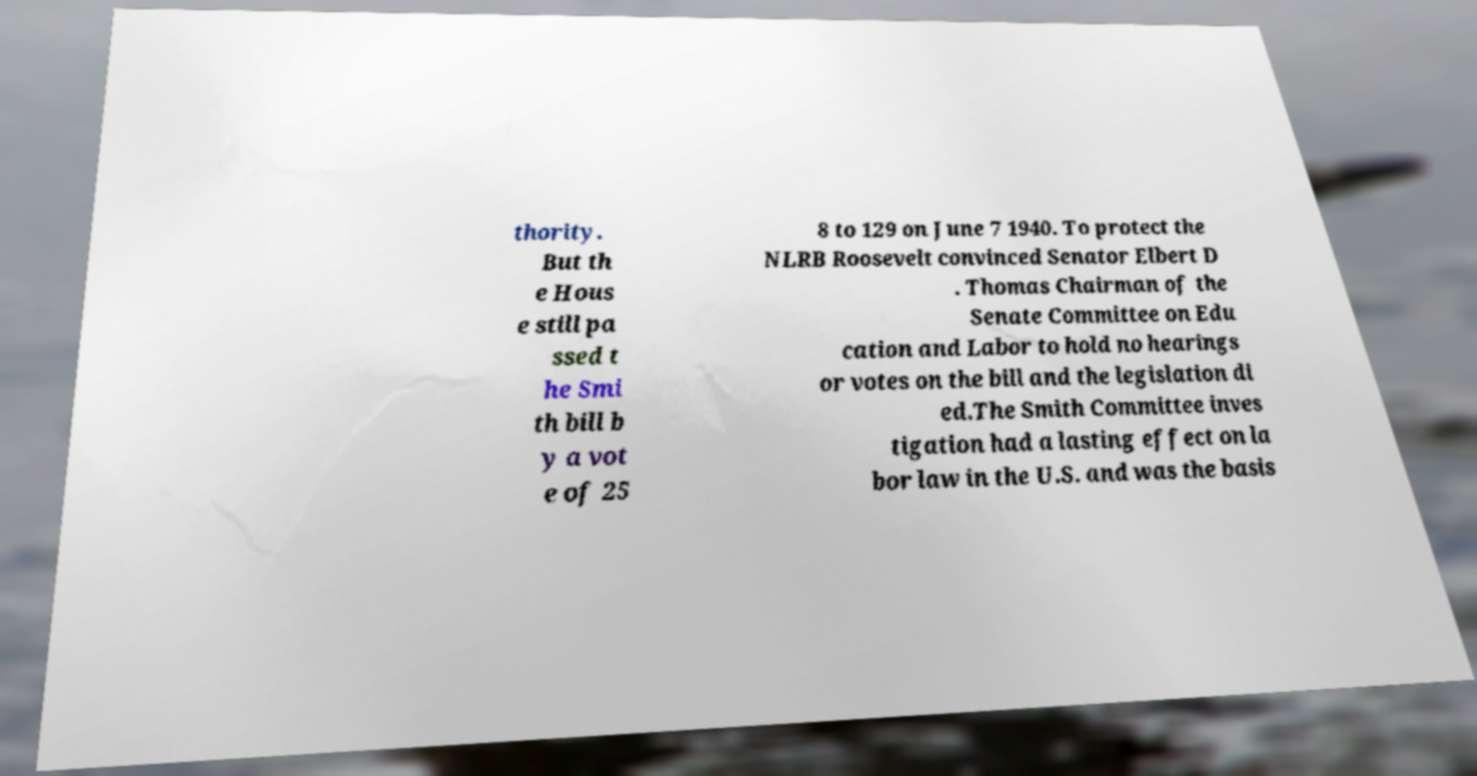For documentation purposes, I need the text within this image transcribed. Could you provide that? thority. But th e Hous e still pa ssed t he Smi th bill b y a vot e of 25 8 to 129 on June 7 1940. To protect the NLRB Roosevelt convinced Senator Elbert D . Thomas Chairman of the Senate Committee on Edu cation and Labor to hold no hearings or votes on the bill and the legislation di ed.The Smith Committee inves tigation had a lasting effect on la bor law in the U.S. and was the basis 